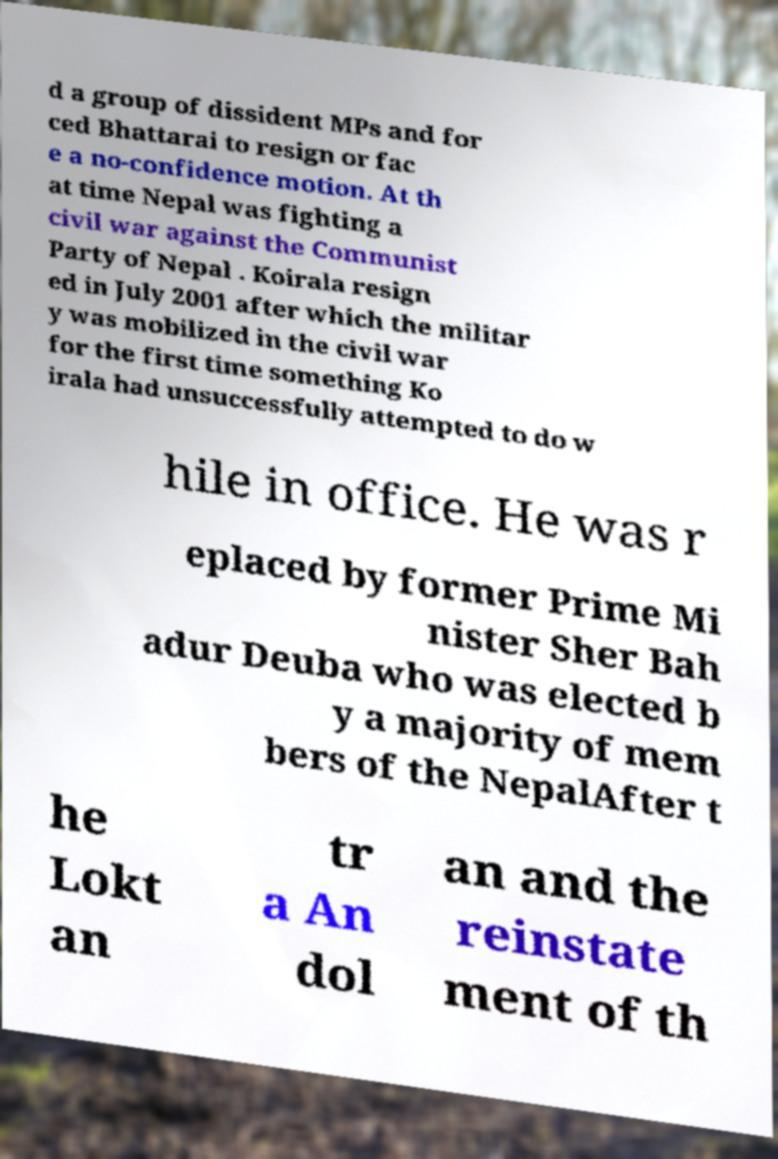Can you read and provide the text displayed in the image?This photo seems to have some interesting text. Can you extract and type it out for me? d a group of dissident MPs and for ced Bhattarai to resign or fac e a no-confidence motion. At th at time Nepal was fighting a civil war against the Communist Party of Nepal . Koirala resign ed in July 2001 after which the militar y was mobilized in the civil war for the first time something Ko irala had unsuccessfully attempted to do w hile in office. He was r eplaced by former Prime Mi nister Sher Bah adur Deuba who was elected b y a majority of mem bers of the NepalAfter t he Lokt an tr a An dol an and the reinstate ment of th 